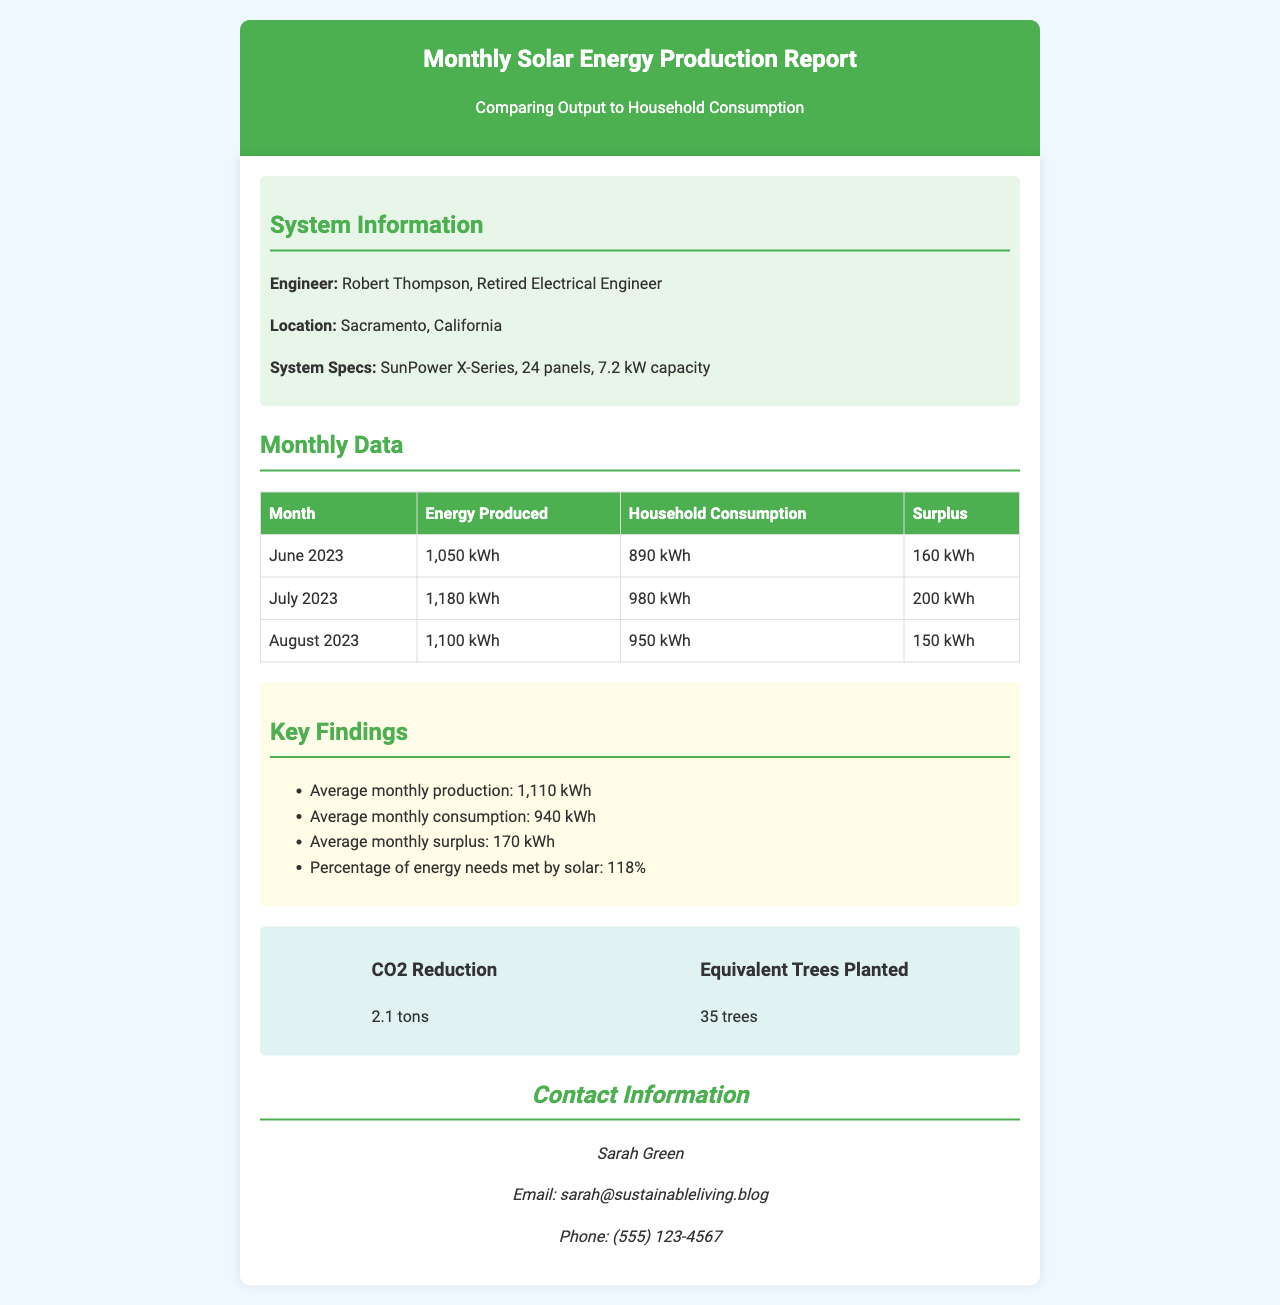What is the engineer's name? The engineer's name is listed in the system information section of the document.
Answer: Robert Thompson What is the location of the solar installation? The location is specified in the system information section.
Answer: Sacramento, California How many solar panels are installed? The number of solar panels is provided in the system specs within the document.
Answer: 24 panels What was the energy produced in July 2023? The energy produced for each month is listed in the monthly data table.
Answer: 1,180 kWh What is the average monthly surplus energy? The average monthly surplus is calculated and presented in the key findings section.
Answer: 170 kWh What percentage of energy needs is met by solar? This value is summarized in the key findings, showing the effectiveness of the solar system.
Answer: 118% How much CO2 was reduced by the solar installation? The CO2 reduction figure is mentioned in the environmental impact section of the document.
Answer: 2.1 tons How many equivalent trees were planted? This figure is also found in the environmental impact section, relating to the CO2 reduction.
Answer: 35 trees Who should be contacted for more information? Contact information is provided towards the end of the document.
Answer: Sarah Green 